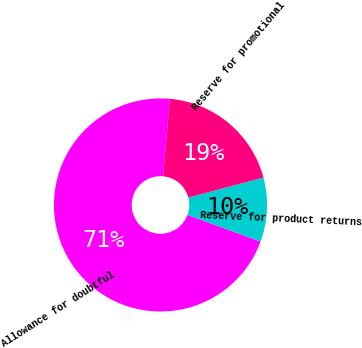<chart> <loc_0><loc_0><loc_500><loc_500><pie_chart><fcel>Allowance for doubtful<fcel>Reserve for product returns<fcel>Reserve for promotional<nl><fcel>70.83%<fcel>9.72%<fcel>19.44%<nl></chart> 